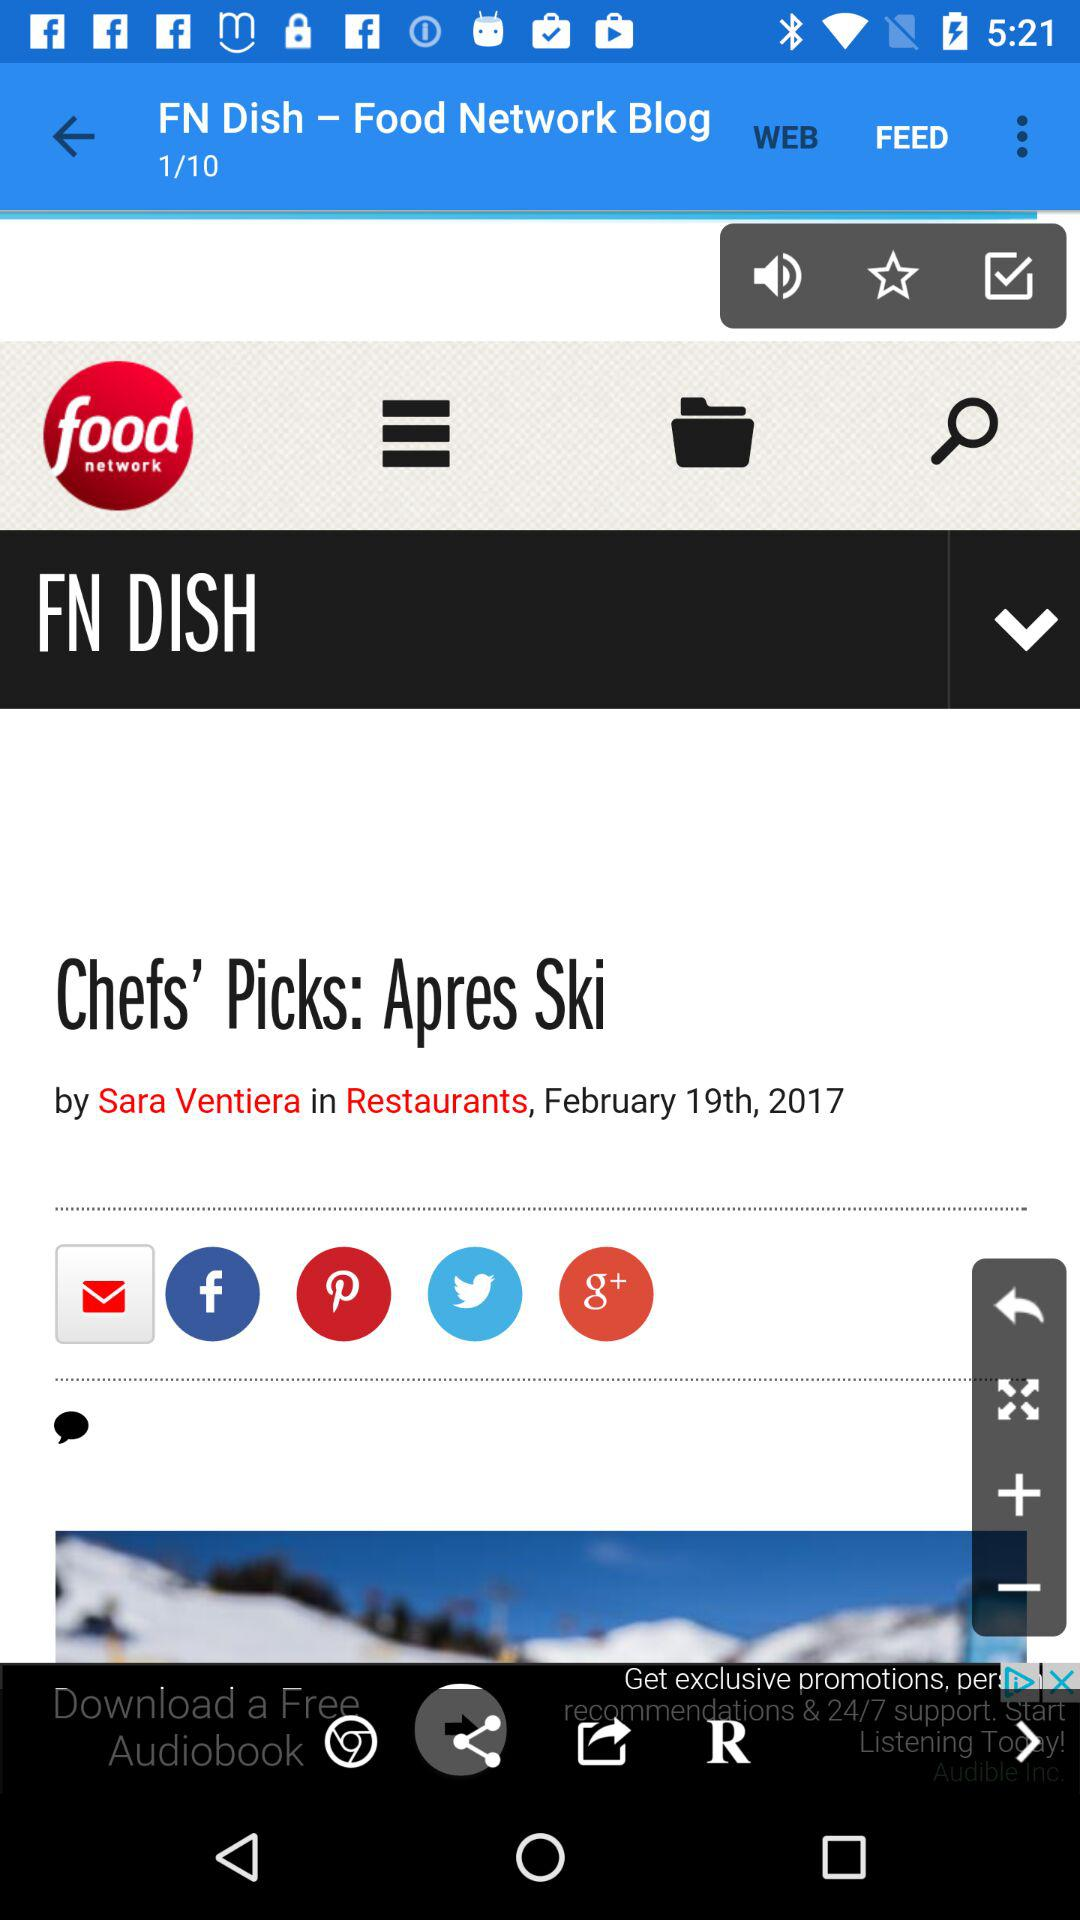Which page are we currently on? You are currently on page 1. 